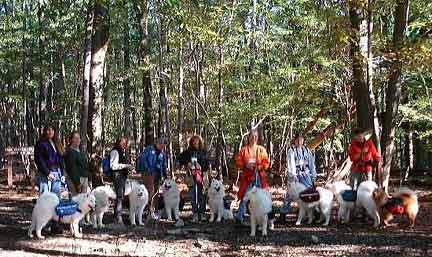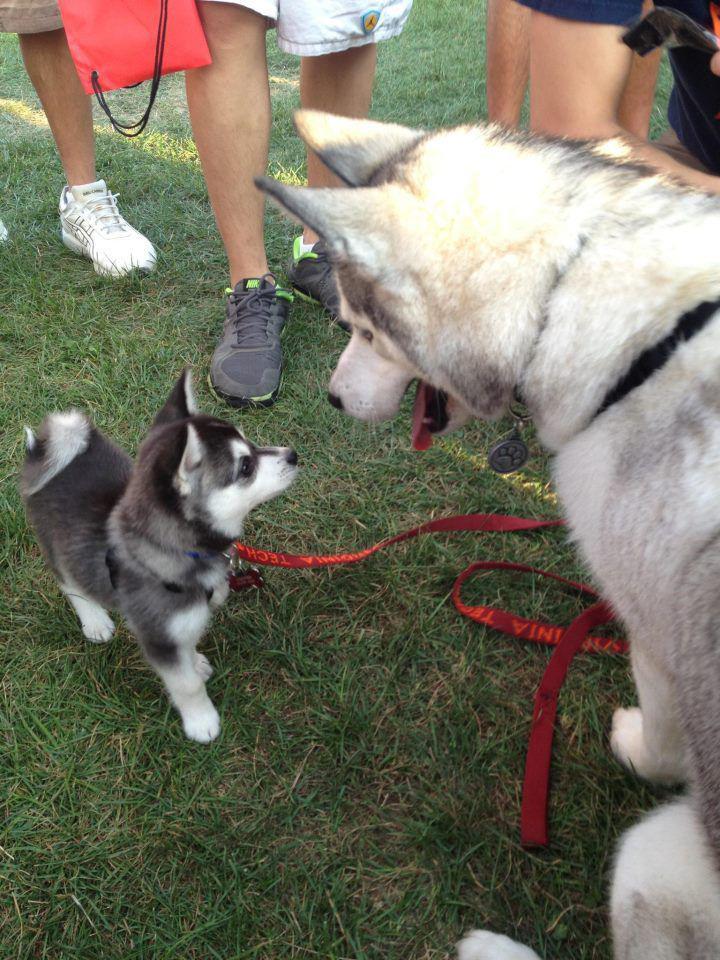The first image is the image on the left, the second image is the image on the right. Given the left and right images, does the statement "One of the white dogs is lying on the green grass." hold true? Answer yes or no. No. The first image is the image on the left, the second image is the image on the right. Given the left and right images, does the statement "An image with one dog shows a person standing outdoors next to the dog on a leash." hold true? Answer yes or no. No. 